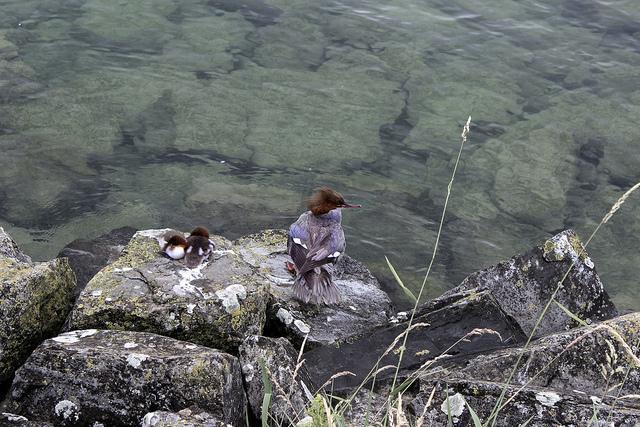How many people are wearing tie?
Give a very brief answer. 0. 